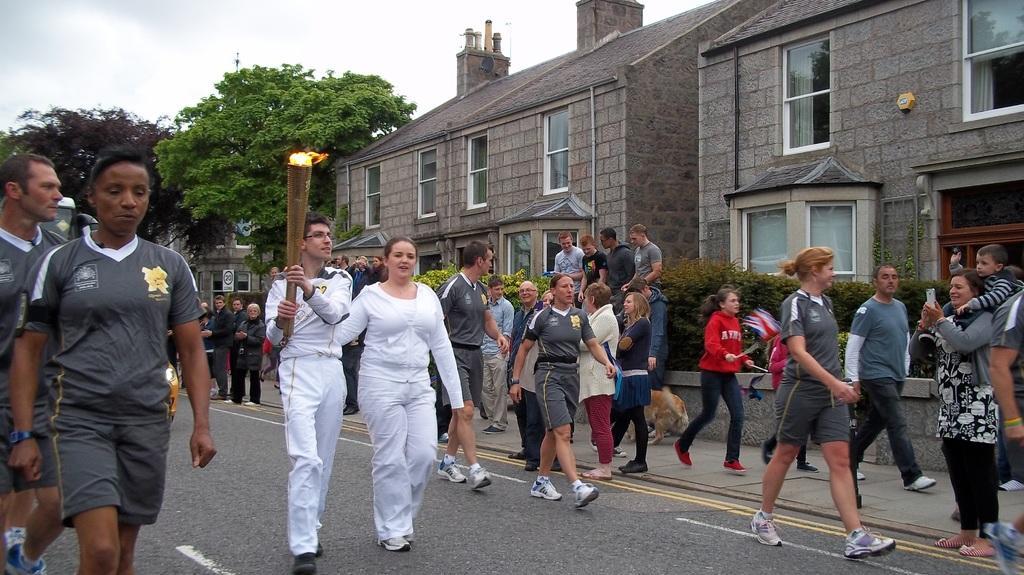Please provide a concise description of this image. In this image we can see people are walking on road and pavement. In the middle of the road one man is walking who is wearing white dress and holding fire lamp in his hand. Right side of the image buildings and trees are present. The sky is full of clouds. 